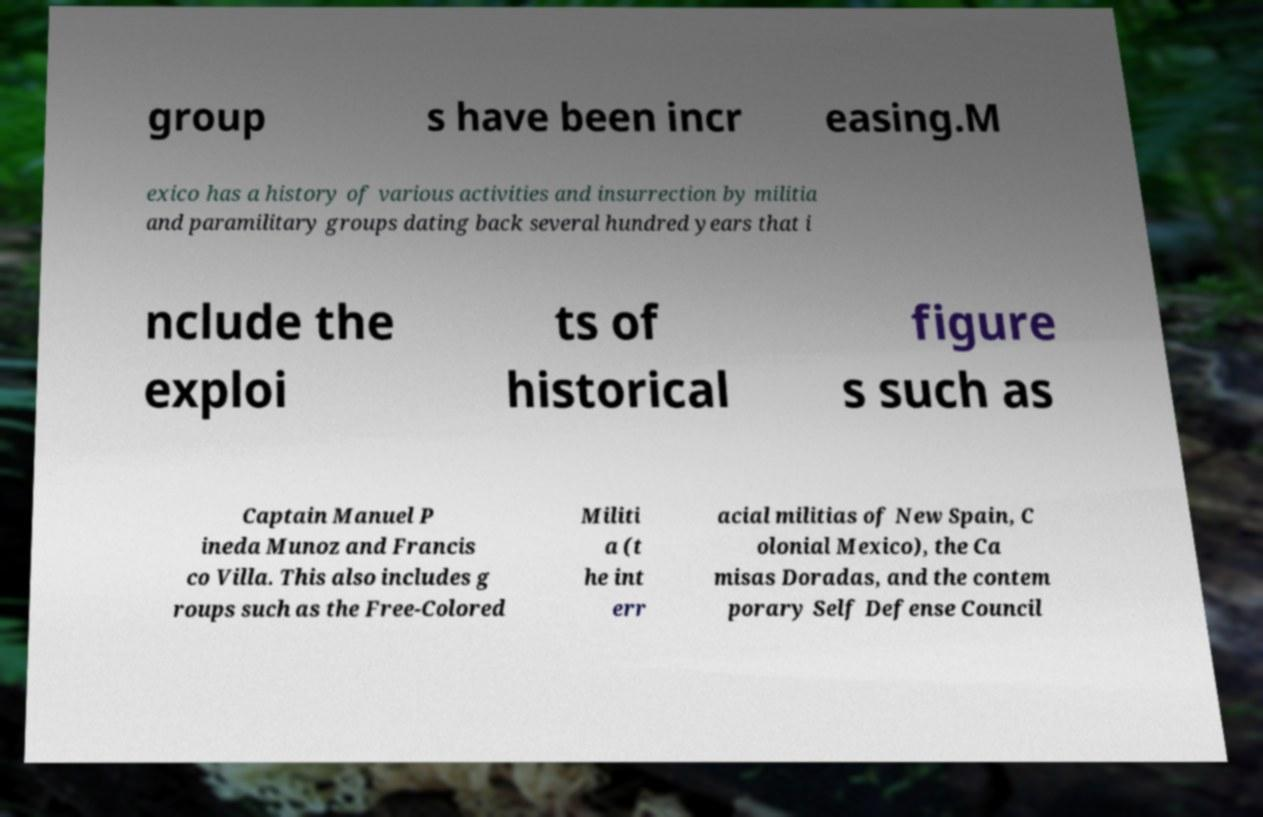Can you accurately transcribe the text from the provided image for me? group s have been incr easing.M exico has a history of various activities and insurrection by militia and paramilitary groups dating back several hundred years that i nclude the exploi ts of historical figure s such as Captain Manuel P ineda Munoz and Francis co Villa. This also includes g roups such as the Free-Colored Militi a (t he int err acial militias of New Spain, C olonial Mexico), the Ca misas Doradas, and the contem porary Self Defense Council 